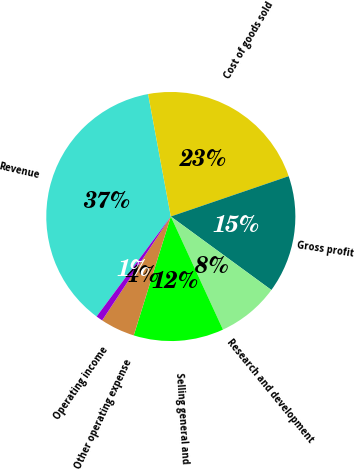Convert chart to OTSL. <chart><loc_0><loc_0><loc_500><loc_500><pie_chart><fcel>Revenue<fcel>Cost of goods sold<fcel>Gross profit<fcel>Research and development<fcel>Selling general and<fcel>Other operating expense<fcel>Operating income<nl><fcel>36.92%<fcel>22.68%<fcel>15.29%<fcel>8.08%<fcel>11.69%<fcel>4.48%<fcel>0.87%<nl></chart> 